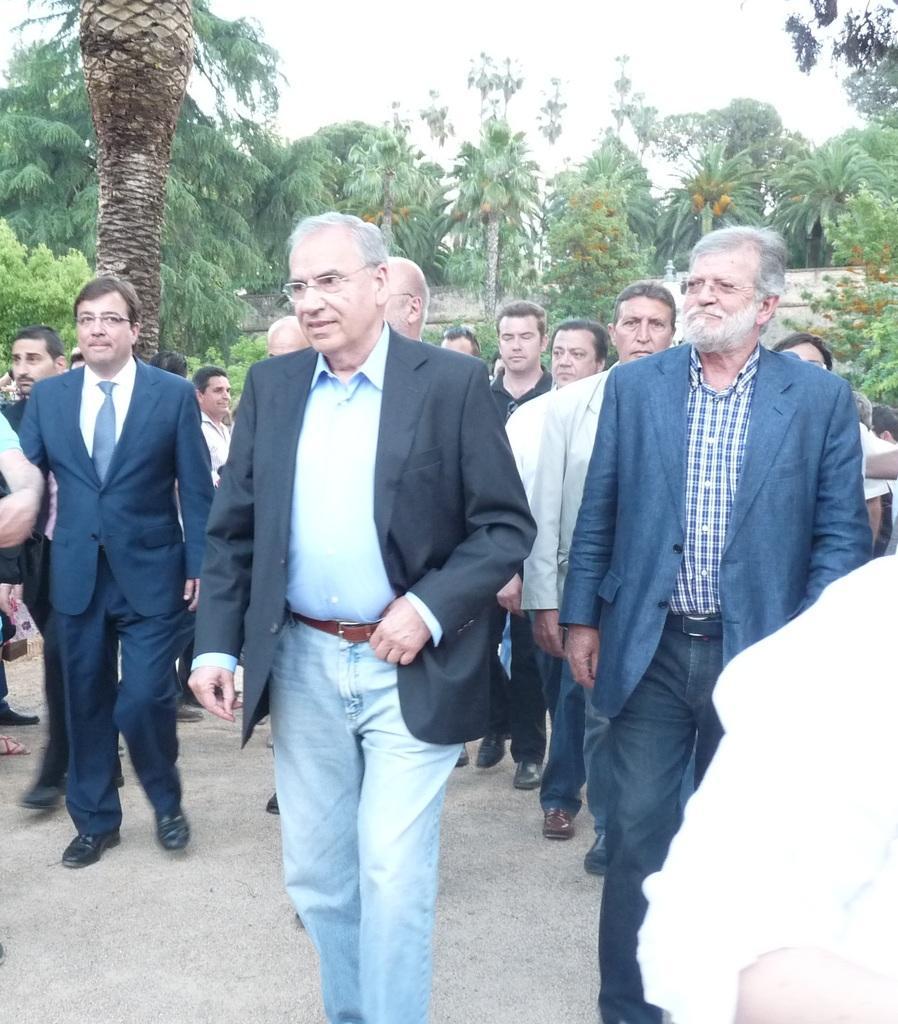Please provide a concise description of this image. In this image I can see group of people some are walking and some are standing, the person in front is wearing black blazer, white shirt and white pant. Background I can see trees in green color and the sky is in white color. 